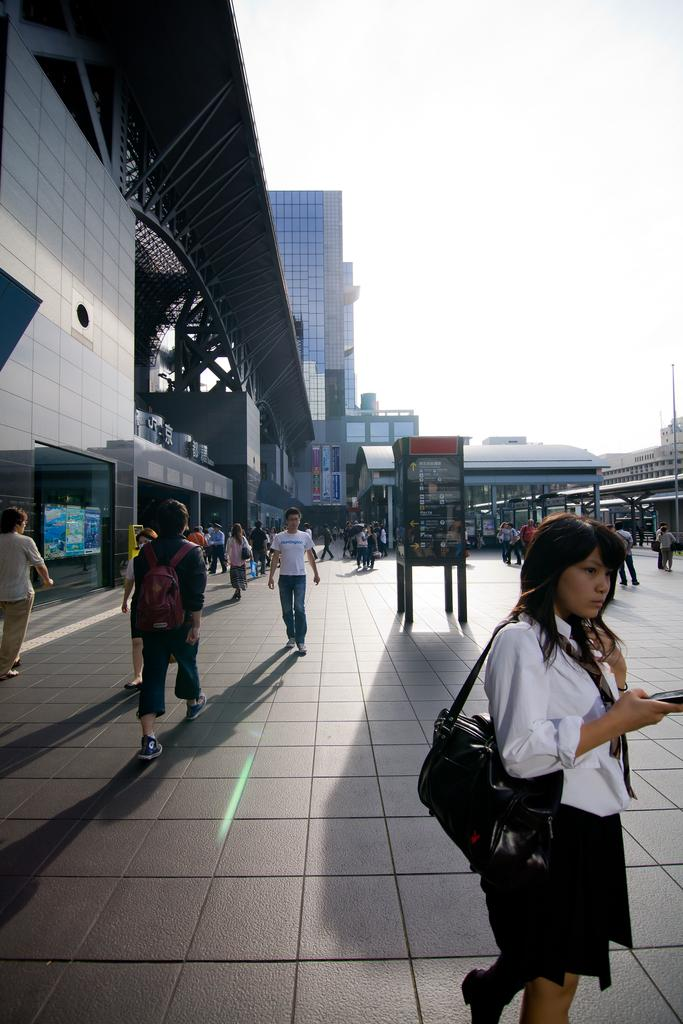What are the people in the image doing? The people in the image are walking on the road. What can be seen in the middle of the image? There is a booth in the middle of the image. What type of structures are visible in the background of the image? There are buildings around the area in the image. What type of nail is being used to teach the people in the image? There is no nail or teaching activity present in the image. 